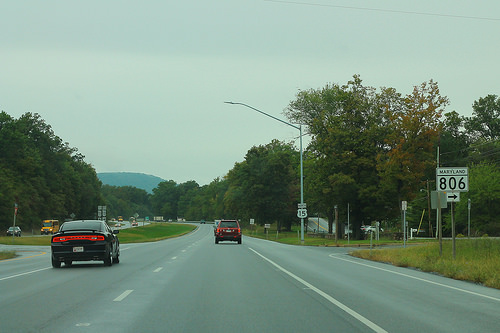<image>
Is the red car behind the black car? No. The red car is not behind the black car. From this viewpoint, the red car appears to be positioned elsewhere in the scene. 